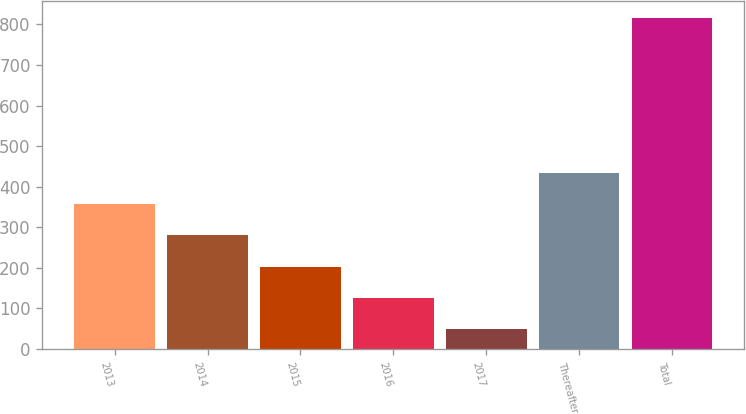<chart> <loc_0><loc_0><loc_500><loc_500><bar_chart><fcel>2013<fcel>2014<fcel>2015<fcel>2016<fcel>2017<fcel>Thereafter<fcel>Total<nl><fcel>356.4<fcel>279.8<fcel>203.2<fcel>126.6<fcel>50<fcel>433<fcel>816<nl></chart> 